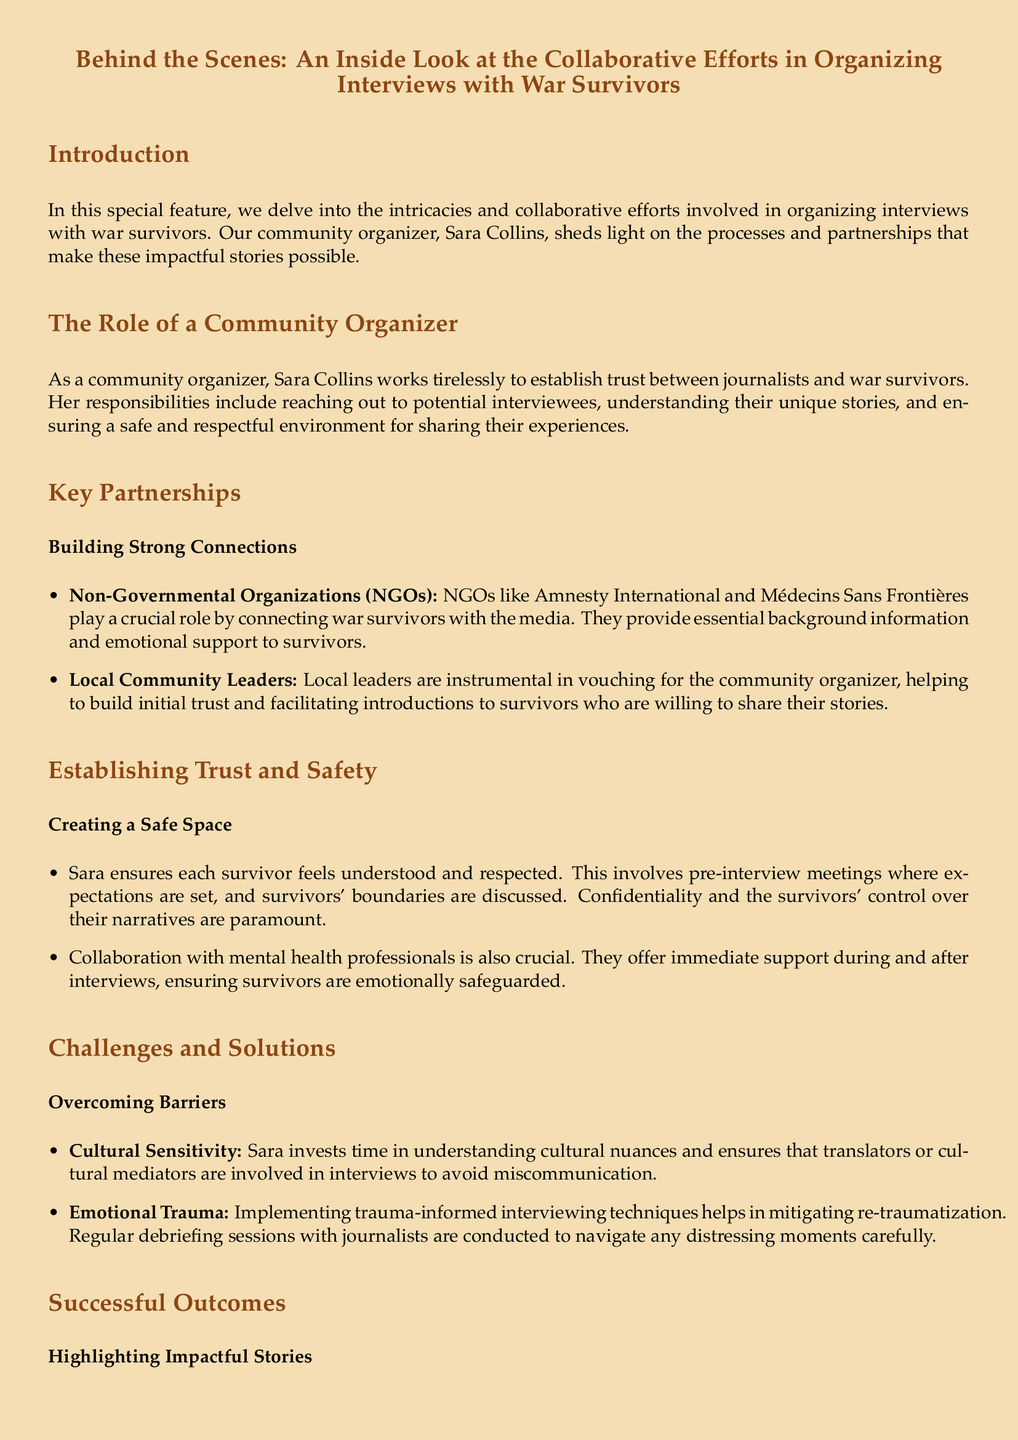What is the title of the document? The title is prominently displayed at the beginning, indicating the focus of the feature.
Answer: Behind the Scenes: An Inside Look at the Collaborative Efforts in Organizing Interviews with War Survivors Who is the community organizer mentioned in the document? The document introduces the community organizer by name in the introduction section.
Answer: Sara Collins Which NGOs are highlighted as important partners? The document lists specific organizations that play a crucial role in connecting survivors with the media.
Answer: Amnesty International and Médecins Sans Frontières What is a key component of creating a safe space for survivors? The document discusses specific actions taken by Sara to ensure a respectful environment for sharing stories.
Answer: Pre-interview meetings What technique is used to mitigate emotional trauma during interviews? The document mentions strategies employed to help prevent re-traumatization for survivors during the interview process.
Answer: Trauma-informed interviewing techniques What did the interview with Hala Magdy highlight? The document provides an example of a successful interview and its significance, showcasing its impact.
Answer: The plight of women and children in the conflict zone What is the purpose of collaboration with mental health professionals? The document explains the importance of involving mental health professionals during and after interviews for the well-being of survivors.
Answer: Emotional support What type of nuance does Sara invest time to understand? The document points out an essential aspect of the interviewing process that addresses potential communication challenges.
Answer: Cultural nuances 